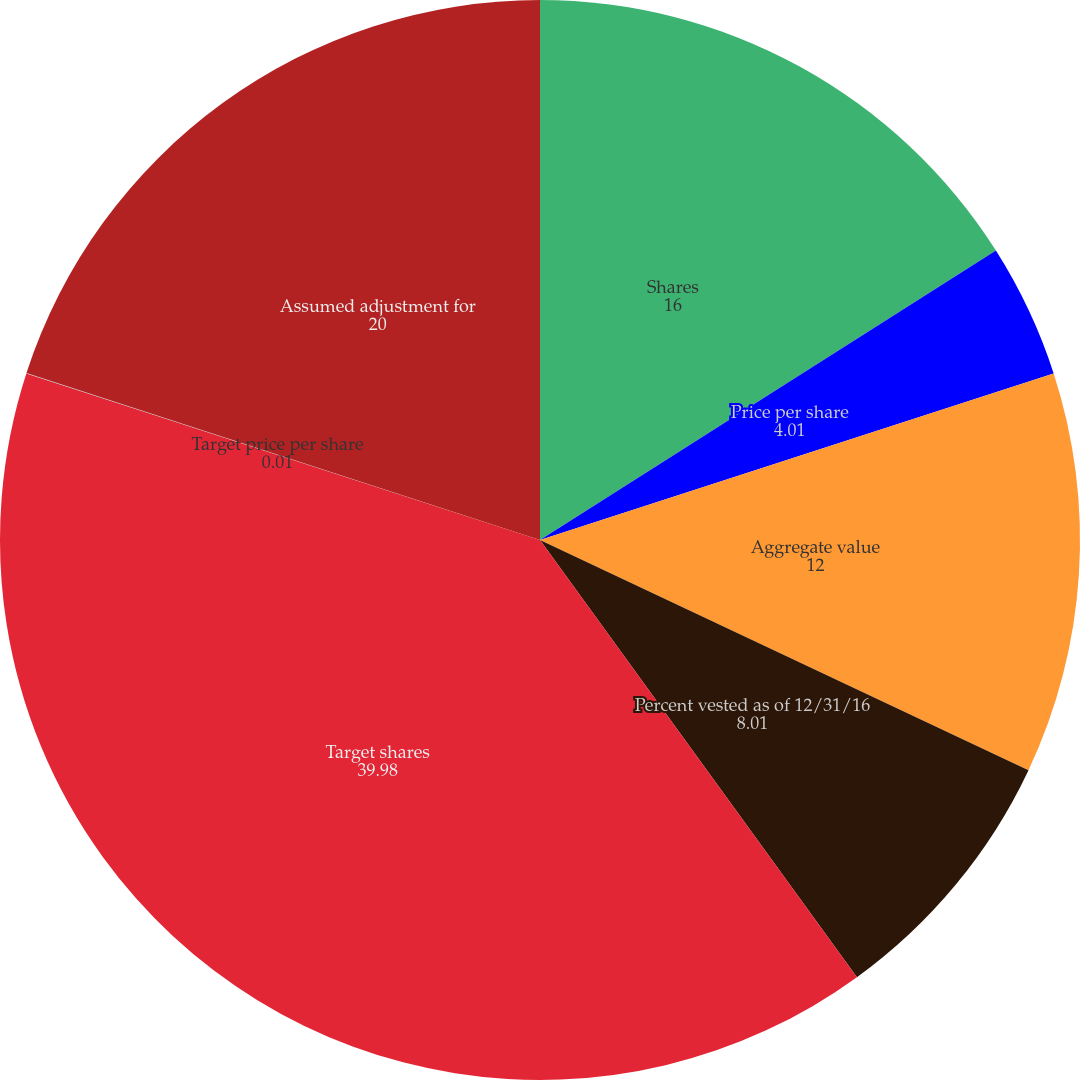Convert chart to OTSL. <chart><loc_0><loc_0><loc_500><loc_500><pie_chart><fcel>Shares<fcel>Price per share<fcel>Aggregate value<fcel>Percent vested as of 12/31/16<fcel>Target shares<fcel>Target price per share<fcel>Assumed adjustment for<nl><fcel>16.0%<fcel>4.01%<fcel>12.0%<fcel>8.01%<fcel>39.98%<fcel>0.01%<fcel>20.0%<nl></chart> 